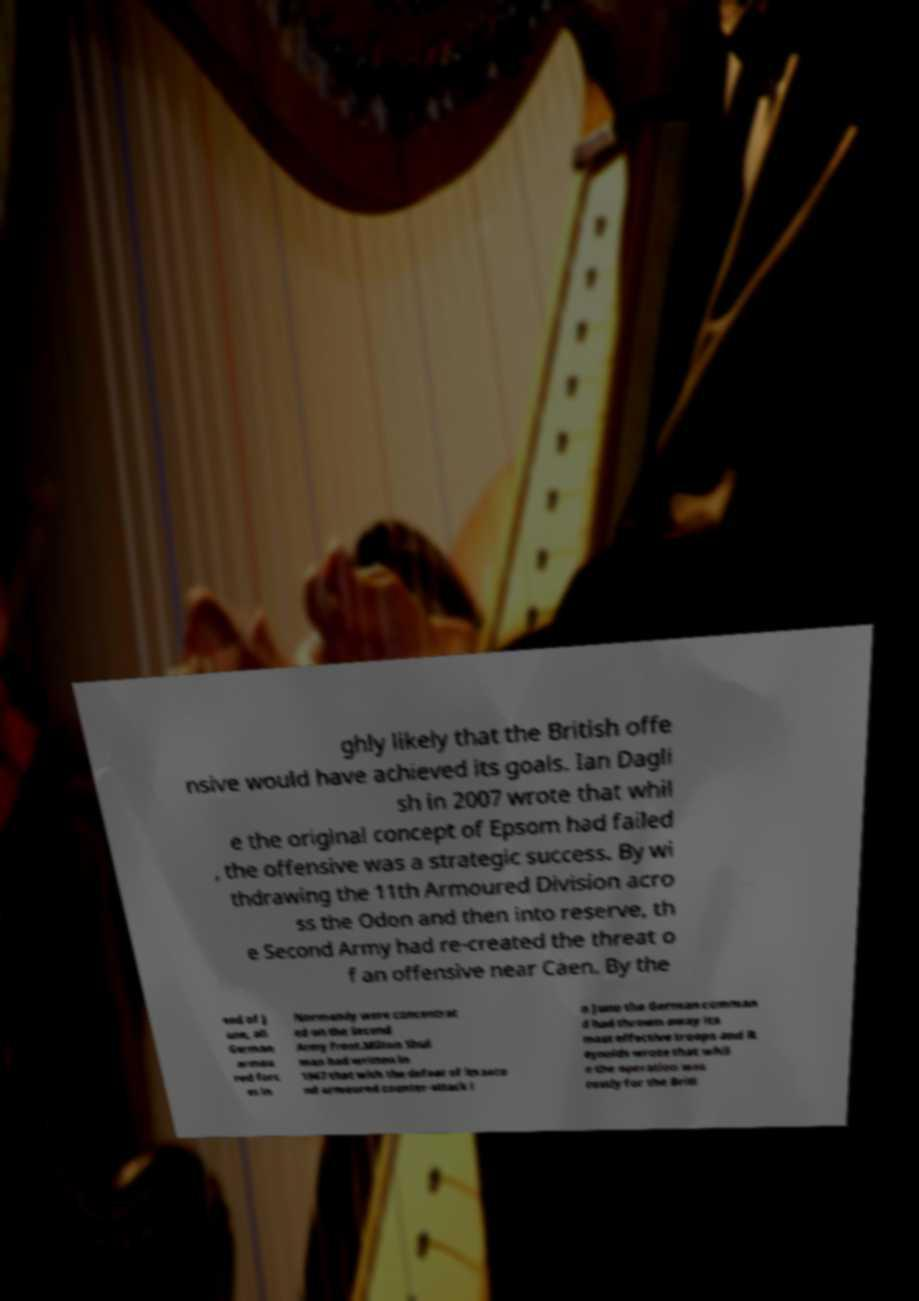Could you extract and type out the text from this image? ghly likely that the British offe nsive would have achieved its goals. Ian Dagli sh in 2007 wrote that whil e the original concept of Epsom had failed , the offensive was a strategic success. By wi thdrawing the 11th Armoured Division acro ss the Odon and then into reserve, th e Second Army had re-created the threat o f an offensive near Caen. By the end of J une, all German armou red forc es in Normandy were concentrat ed on the Second Army front.Milton Shul man had written in 1947 that with the defeat of its seco nd armoured counter-attack i n June the German comman d had thrown away its most effective troops and R eynolds wrote that whil e the operation was costly for the Briti 